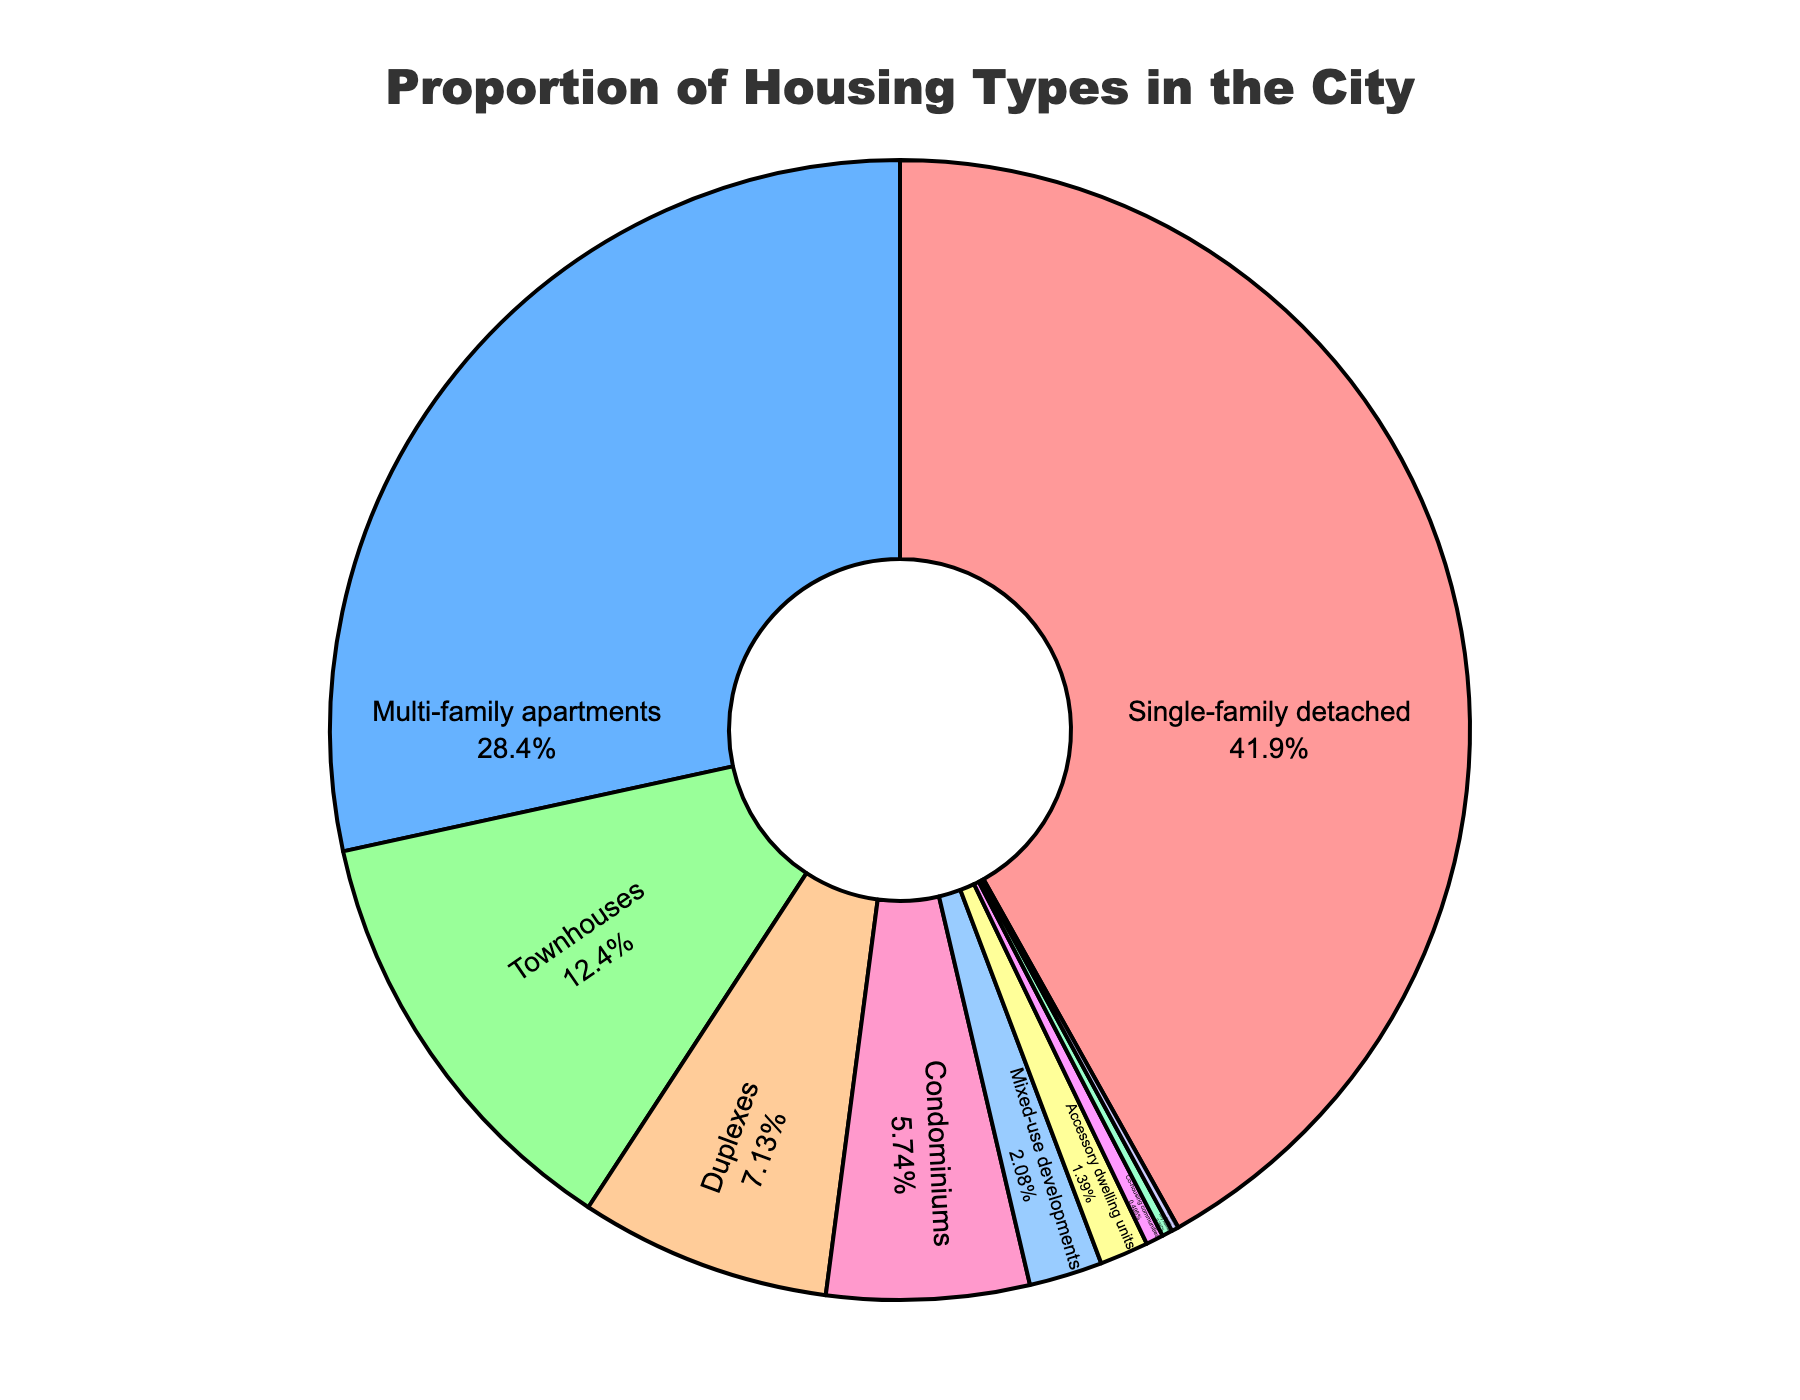What percentage of housing types are made up by Single-family detached and Townhouses combined? To determine the combined percentage, add the percentage of Single-family detached (42.3%) and Townhouses (12.5%): 42.3 + 12.5 = 54.8%
Answer: 54.8% Which housing type accounts for the smallest proportion? Scan through the pie chart labels and percentages to identify the smallest value. Live-work units have the smallest proportion at 0.2%
Answer: Live-work units Does Multi-family apartments have a greater proportion than all smaller percentages combined? First, list all smaller percentages: Townhouses (12.5%), Duplexes (7.2%), Condominiums (5.8%), Mixed-use developments (2.1%), Accessory dwelling units (1.4%), Co-housing communities (0.5%), Tiny homes (0.3%), Live-work units (0.2%). Add these percentages: 12.5 + 7.2 + 5.8 + 2.1 + 1.4 + 0.5 + 0.3 + 0.2 = 30%. Multi-family apartments have 28.7%, which is not greater than 30%
Answer: No Which housing type has a higher proportion: Townhouses or Duplexes? Compare the percentages for Townhouses (12.5%) and Duplexes (7.2%). 12.5% is greater than 7.2%
Answer: Townhouses What is the combined proportion of housing types that are below 2%? List all relevant types: Mixed-use developments (2.1%), Accessory dwelling units (1.4%), Co-housing communities (0.5%), Tiny homes (0.3%), Live-work units (0.2%). Add their percentages (1.4 + 0.5 + 0.3 + 0.2): 1.4 + 0.5 + 0.3 + 0.2 = 2.4%
Answer: 2.4% What color represents Townhouses on the chart? By examining the pie chart's color distribution and labels, the color labeled "Townhouses" should be identified. From the chart, Townhouses are represented in a green color shade.
Answer: Green Is the proportion of Duplexes greater than that of Condominiums plus Tiny Homes? Compare their percentages: Duplexes (7.2%), Condominiums (5.8%), and Tiny Homes (0.3%). Add Condominiums and Tiny Homes (5.8 + 0.3 = 6.1%). 7.2% is greater than 6.1%
Answer: Yes Which housing types are represented using intermediate colors between red and blue? By examining the color distribution on the pie chart and knowing the label information: Intermediate colors between red and blue are represented by Townhouses (green), Duplexes (orange), and Condominiums (pink)
Answer: Townhouses, Duplexes, and Condominiums What proportion does the largest housing type represent compared to the smallest? Largest housing type is Single-family detached (42.3%), smallest is Live-work units (0.2%). Compute the ratio (division): 42.3 / 0.2 = 211.5
Answer: 211.5 What is the second most common housing type, and what percentage does it make up? Looking at the pie chart, Multi-family apartments is the second largest with a percentage of 28.7%
Answer: Multi-family apartments, 28.7% 